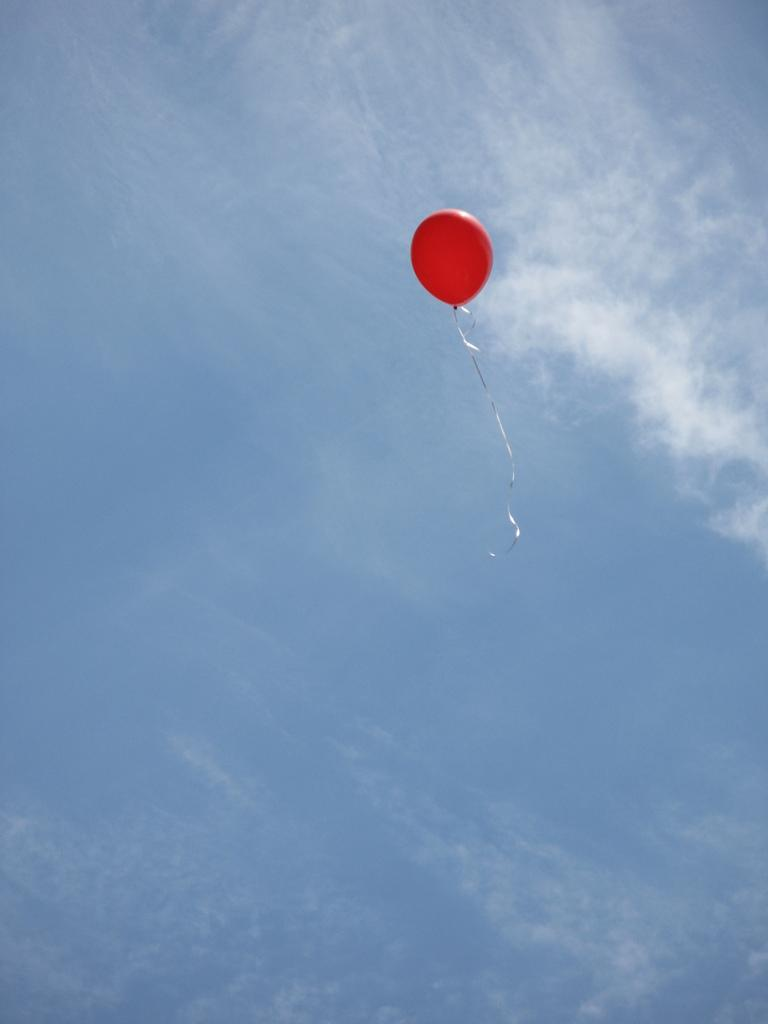What object can be seen in the image? There is a balloon in the image. What can be seen in the background of the image? The sky is visible in the background of the image. What type of health supplement is present in the image? There is no health supplement present in the image; it only features a balloon and the sky. 